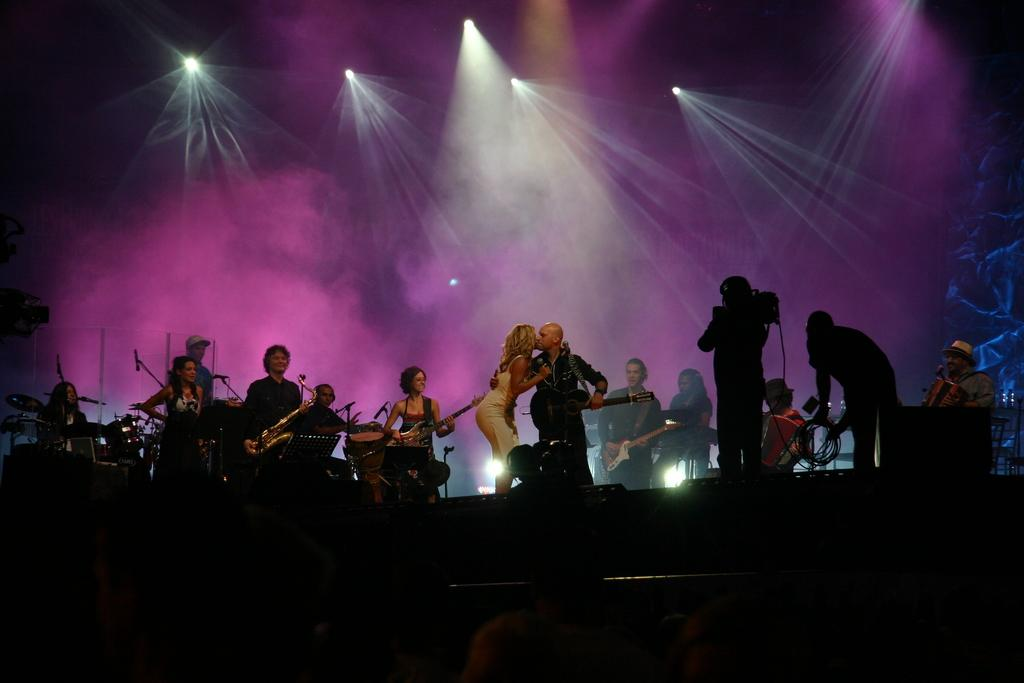What is happening in the image? There is a group of people in the image, and they are standing on a stage. What are some of the people in the group doing? Some people in the group are playing musical instruments. What can be seen in the background of the image? There are lights and smoke visible in the background of the image. What type of pan is being used by the friends in the image? There are no friends or pans present in the image. What type of work are the people in the image doing? The image does not show the people working; they are standing on a stage and playing musical instruments. 